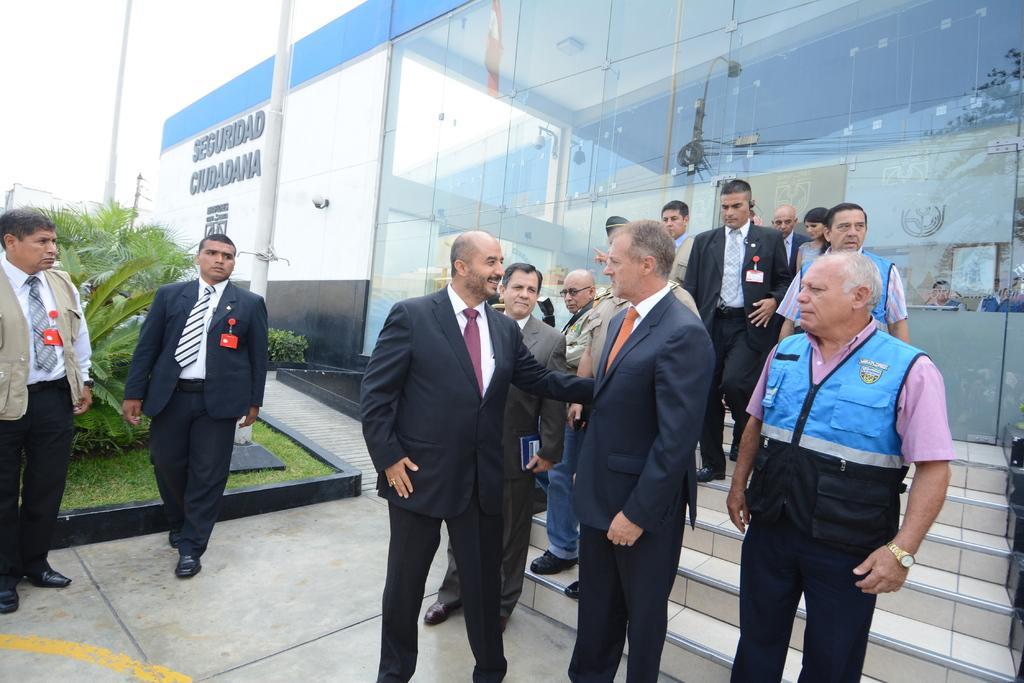In one or two sentences, can you explain what this image depicts? In this image there are a few people standing and talking with each other, behind the persons there are stairs to a building, to the left of the image there are trees. 